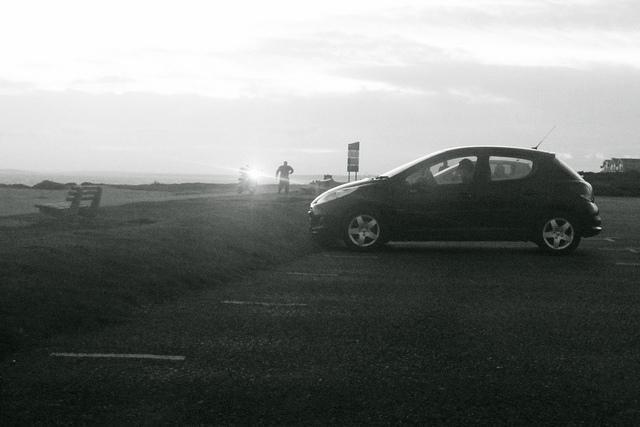How many vehicles are blue?
Give a very brief answer. 0. How many cars are in the picture?
Give a very brief answer. 1. 